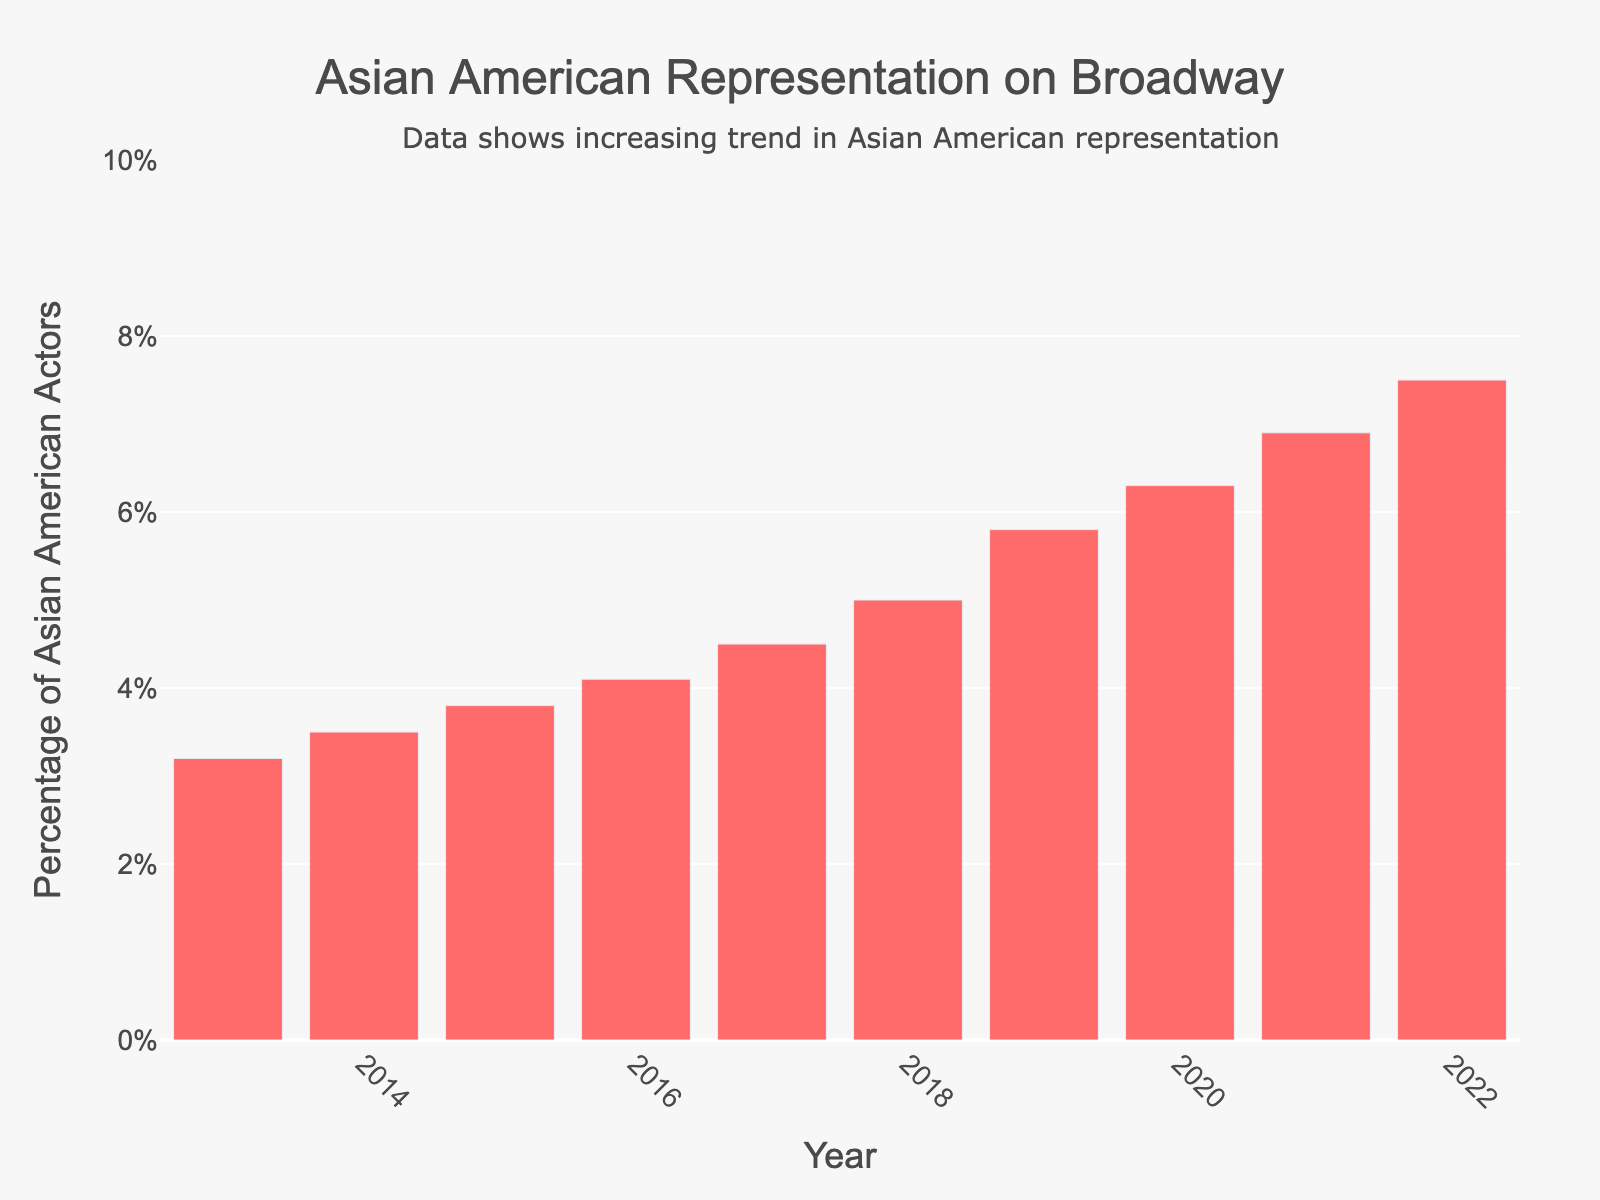What's the percentage increase from 2013 to 2022? The percentage in 2013 is 3.2% and in 2022 is 7.5%. The increase is 7.5% - 3.2% = 4.3%.
Answer: 4.3% What is the average percentage of Asian American actors from 2013 to 2022? Sum the percentages from all years: 3.2 + 3.5 + 3.8 + 4.1 + 4.5 + 5.0 + 5.8 + 6.3 + 6.9 + 7.5 = 50.6%. Then divide by the number of years: 50.6 / 10 = 5.06%.
Answer: 5.06% Between which consecutive years did the percentage increase the most? Calculate the differences between consecutive years: (2014-2013)=0.3, (2015-2014)=0.3, (2016-2015)=0.3, (2017-2016)=0.4, (2018-2017)=0.5, (2019-2018)=0.8, (2020-2019)=0.5, (2021-2020)=0.6, (2022-2021)=0.6. The largest increase is between 2018 and 2019 (0.8%).
Answer: 2018-2019 Which year had the smallest percentage of Asian American actors? Look at the percentages for each year: the smallest is in 2013 with 3.2%.
Answer: 2013 How does the percentage in 2019 compare to 2016? The percentage in 2019 is 5.8% and in 2016 it is 4.1%. 5.8% > 4.1%.
Answer: Higher What's the median percentage from 2013 to 2022? List the percentages in order: [3.2, 3.5, 3.8, 4.1, 4.5, 5.0, 5.8, 6.3, 6.9, 7.5]. The median is the average of the middle two values, (4.5 + 5.0)/2 = 4.75%.
Answer: 4.75% Which year saw the highest percentage of Asian American actors? Look at the percentages for each year; the highest is in 2022 with 7.5%.
Answer: 2022 